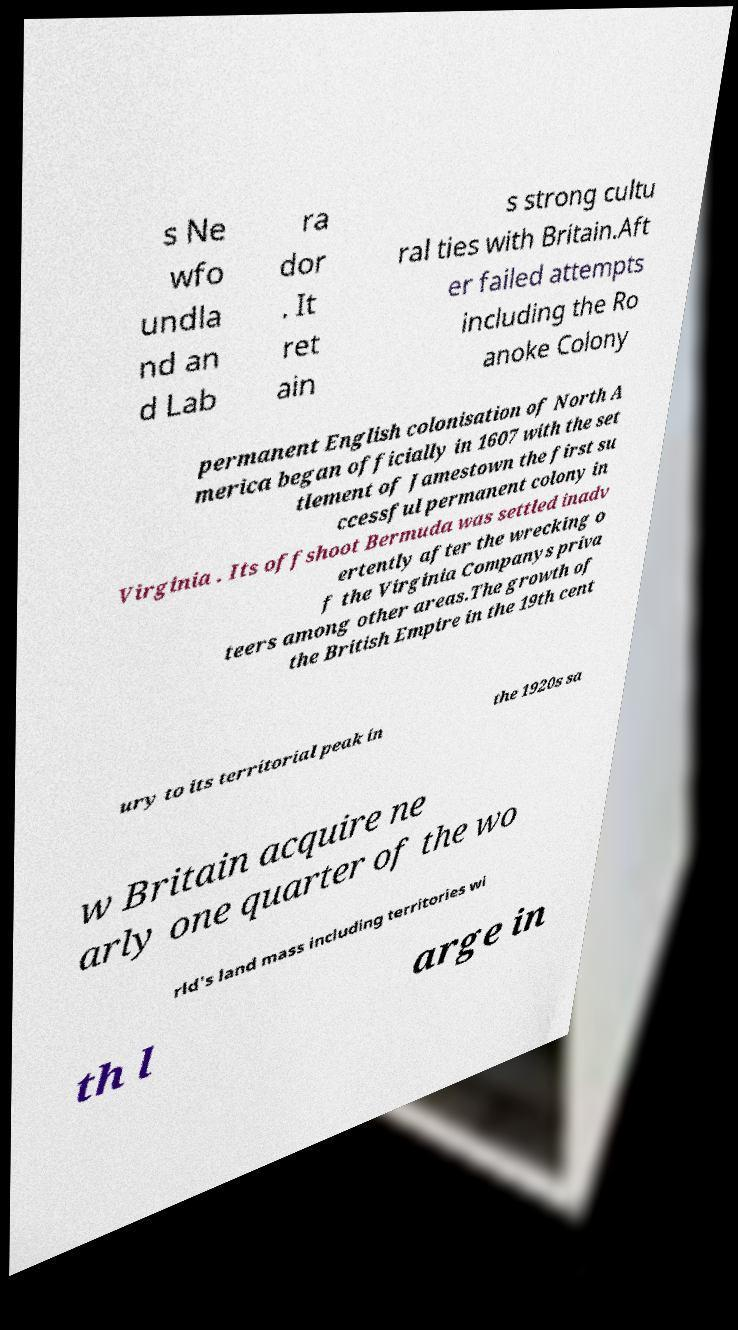For documentation purposes, I need the text within this image transcribed. Could you provide that? s Ne wfo undla nd an d Lab ra dor . It ret ain s strong cultu ral ties with Britain.Aft er failed attempts including the Ro anoke Colony permanent English colonisation of North A merica began officially in 1607 with the set tlement of Jamestown the first su ccessful permanent colony in Virginia . Its offshoot Bermuda was settled inadv ertently after the wrecking o f the Virginia Companys priva teers among other areas.The growth of the British Empire in the 19th cent ury to its territorial peak in the 1920s sa w Britain acquire ne arly one quarter of the wo rld's land mass including territories wi th l arge in 